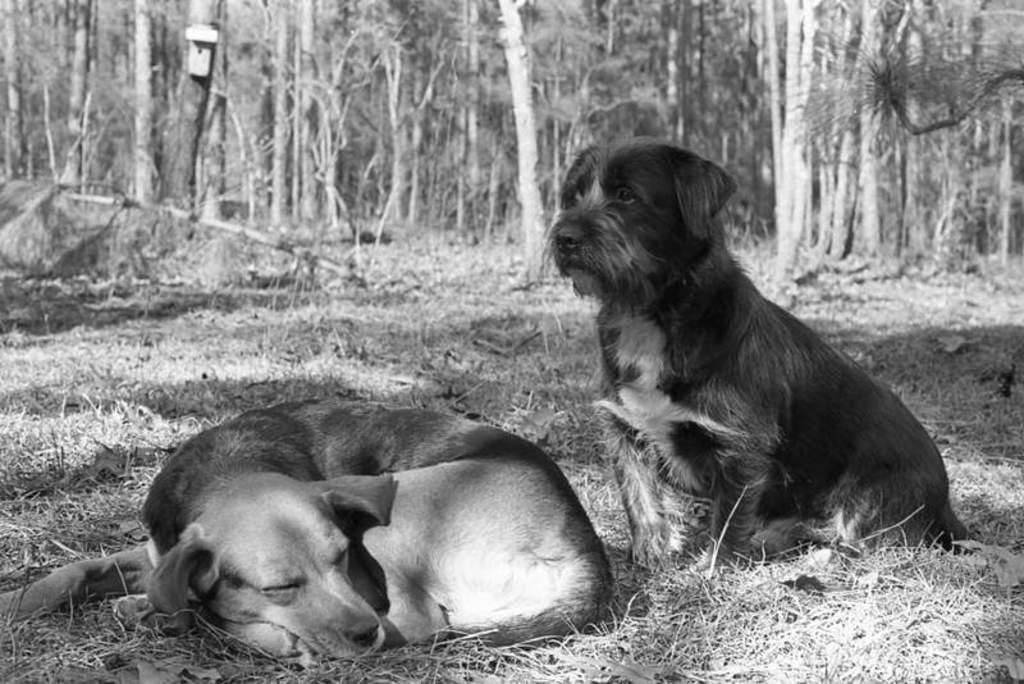How many dogs are in the image? There are two dogs in the image. What is the position of the first dog? The first dog is sleeping on the left side. What is the position of the second dog? The second dog is sitting on the right side. What type of vegetation is visible at the bottom of the image? There is grass at the bottom of the image. What can be seen in the background of the image? Trees are present in the background of the image. What type of fish is being served for dinner in the image? There is no dinner or fish present in the image; it features two dogs in different positions. How are the dogs being transported in the image? The dogs are not being transported in the image; they are stationary in their respective positions. 